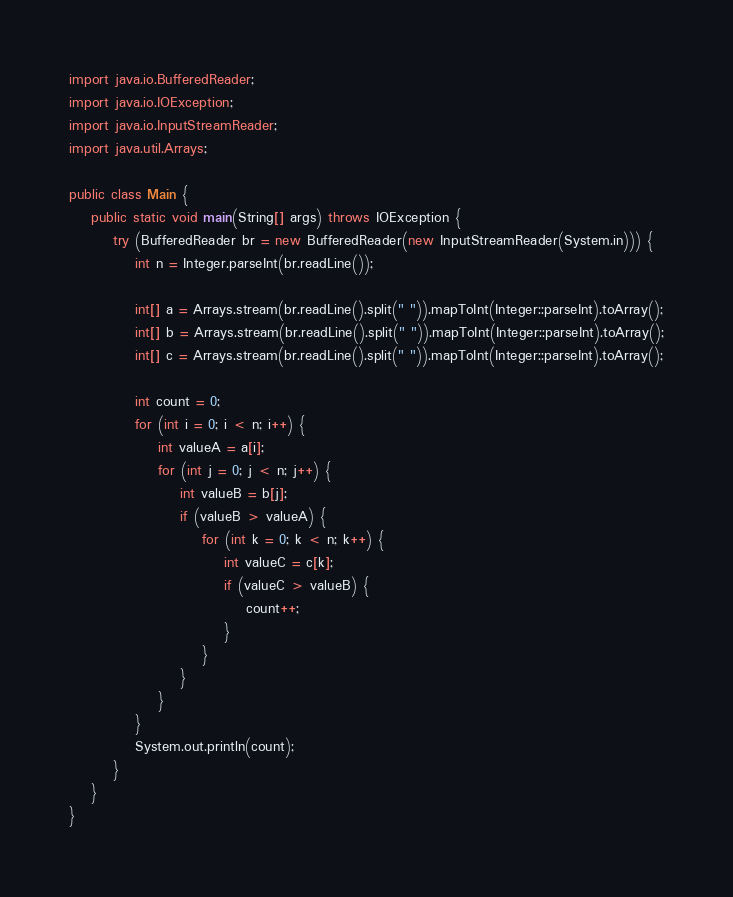<code> <loc_0><loc_0><loc_500><loc_500><_Java_>
import java.io.BufferedReader;
import java.io.IOException;
import java.io.InputStreamReader;
import java.util.Arrays;

public class Main {
	public static void main(String[] args) throws IOException {
		try (BufferedReader br = new BufferedReader(new InputStreamReader(System.in))) {
			int n = Integer.parseInt(br.readLine());

			int[] a = Arrays.stream(br.readLine().split(" ")).mapToInt(Integer::parseInt).toArray();
			int[] b = Arrays.stream(br.readLine().split(" ")).mapToInt(Integer::parseInt).toArray();
			int[] c = Arrays.stream(br.readLine().split(" ")).mapToInt(Integer::parseInt).toArray();

			int count = 0;
			for (int i = 0; i < n; i++) {
				int valueA = a[i];
				for (int j = 0; j < n; j++) {
					int valueB = b[j];
					if (valueB > valueA) {
						for (int k = 0; k < n; k++) {
							int valueC = c[k];
							if (valueC > valueB) {
								count++;
							}
						}
					}
				}
			}
			System.out.println(count);
		}
	}
}
</code> 